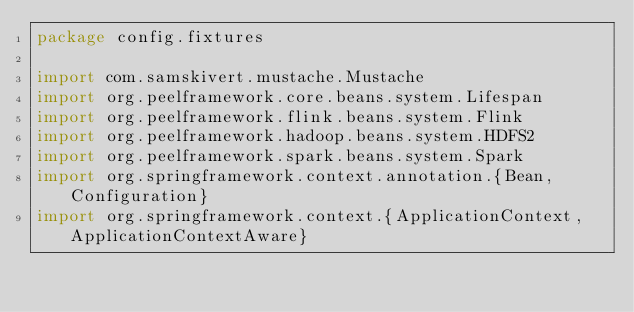Convert code to text. <code><loc_0><loc_0><loc_500><loc_500><_Scala_>package config.fixtures

import com.samskivert.mustache.Mustache
import org.peelframework.core.beans.system.Lifespan
import org.peelframework.flink.beans.system.Flink
import org.peelframework.hadoop.beans.system.HDFS2
import org.peelframework.spark.beans.system.Spark
import org.springframework.context.annotation.{Bean, Configuration}
import org.springframework.context.{ApplicationContext, ApplicationContextAware}
</code> 